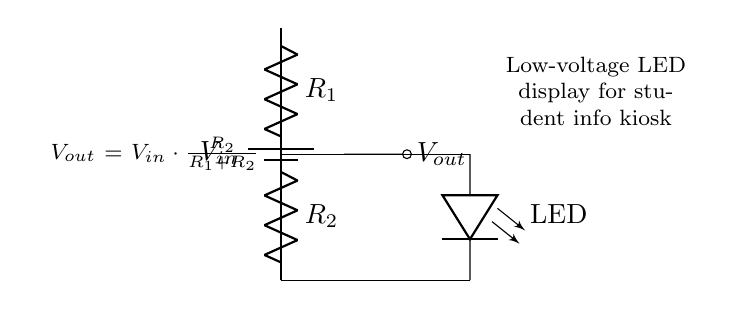What is the input voltage in the circuit? The input voltage is denoted as V in the diagram, referring to the voltage supplied by the battery.
Answer: V in What are the two resistors in this voltage divider? The two resistors are labeled R1 and R2 in the circuit diagram, which divide the input voltage to produce the output voltage.
Answer: R1, R2 What is the output voltage formula shown in the circuit? The output voltage formula is provided as "V out = V in * (R2 / (R1 + R2))", which expresses how the output voltage is determined by the input voltage and the values of the resistors.
Answer: V out = V in * (R2 / (R1 + R2)) How does increasing R2 affect V out? Increasing R2 will increase the output voltage V out because the formula shows a direct proportional relationship between R2 and V out, assuming V in is constant.
Answer: V out increases What is connected to the output V out? The output V out is connected to an LED, as shown in the circuit diagram, indicating that the output voltage is used to power the LED display.
Answer: LED What is the purpose of the voltage divider in this circuit? The voltage divider's purpose is to step down the input voltage to a lower voltage suitable for operating the low-voltage LED display in the student information kiosk.
Answer: Provide suitable voltage for LED display What does the circuit annotate as the LED display's role? The circuit annotates that the LED display provides information in student kiosks, indicating its application in an educational setting.
Answer: Student information kiosk 